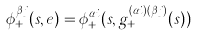<formula> <loc_0><loc_0><loc_500><loc_500>\phi ^ { \beta j } _ { + } ( s , e ) = \phi ^ { \alpha i } _ { + } ( s , g ^ { ( \alpha i ) ( \beta j ) } _ { + } ( s ) )</formula> 